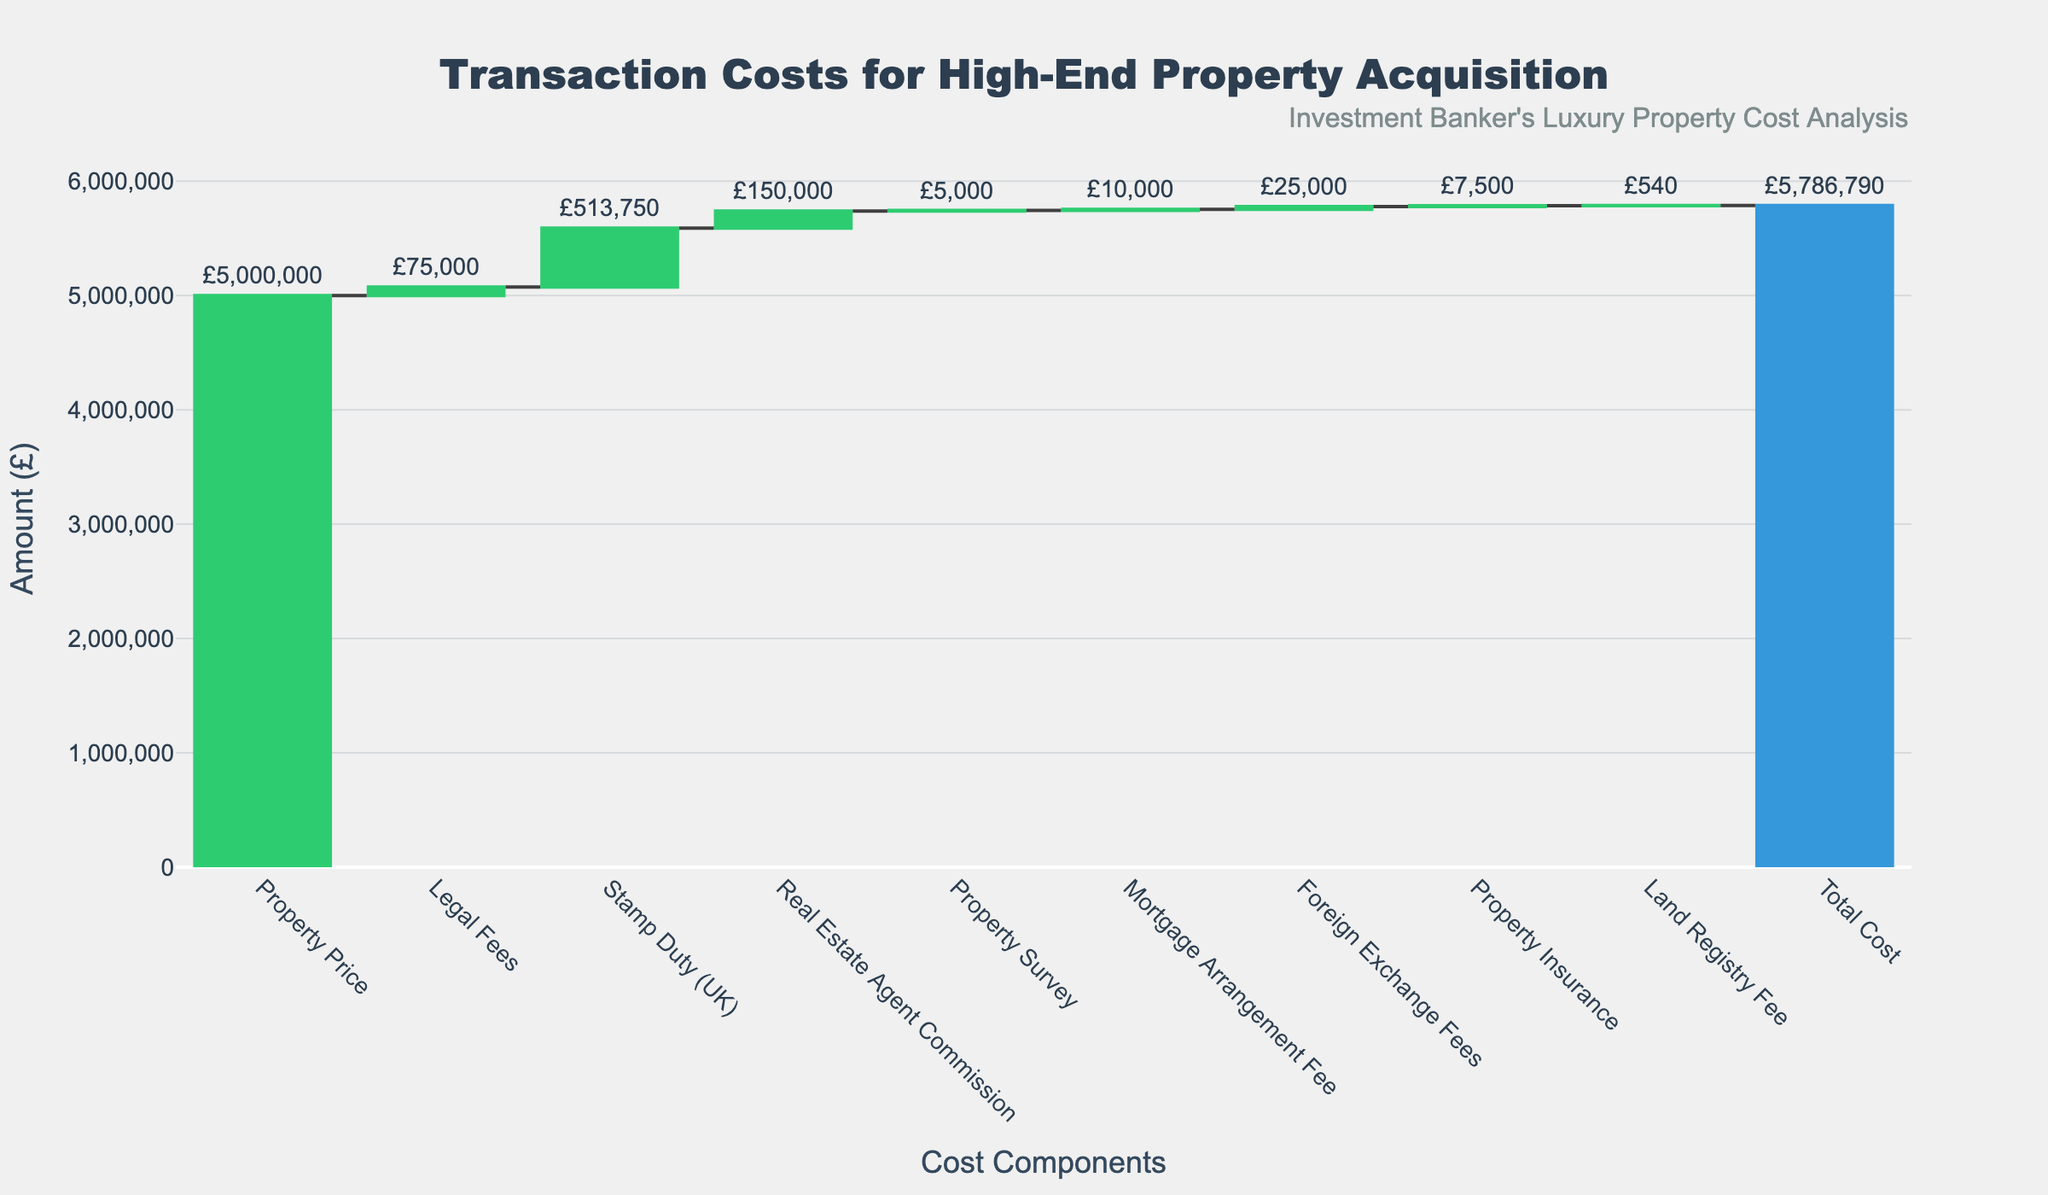What is the total cost of acquiring the property? The total cost is clearly labeled at the bottom of the chart as "Total Cost".
Answer: £5,786,790 How much does the stamp duty cost? The stamp duty cost is shown as “Stamp Duty (UK)" in the figure.
Answer: £513,750 Which fee is the smallest and how much is it? The smallest fee in the waterfall chart is the "Land Registry Fee".
Answer: £540 How much is the property price alone? The property price is labeled directly as "Property Price" in the plot.
Answer: £5,000,000 What is the total cost increase due to legal fees, real estate agent commission, and mortgage arrangement fee? Sum up the "Legal Fees" (£75,000), "Real Estate Agent Commission" (£150,000), and "Mortgage Arrangement Fee" (£10,000).
Answer: £235,000 How does the property survey fee compare to the foreign exchange fees? The property survey fee is £5,000, while the foreign exchange fees are £25,000.
Answer: Property survey fee is £20,000 less What’s the combined cost of property insurance and land registry fee? Add the "Property Insurance" (£7,500) and "Land Registry Fee" (£540).
Answer: £8,040 What is the most significant cost after the property price and what is its value? After "Property Price", the next most significant cost is "Stamp Duty (UK)".
Answer: £513,750 How much do legal fees and property survey together affect the total cost? Sum "Legal Fees" (£75,000) and "Property Survey" (£5,000).
Answer: £80,000 What’s the proportion of the real estate agent commission in relation to the property price? Divide the "Real Estate Agent Commission" (£150,000) by the "Property Price" (£5,000,000) and multiply by 100 to get the percentage.
Answer: 3% 